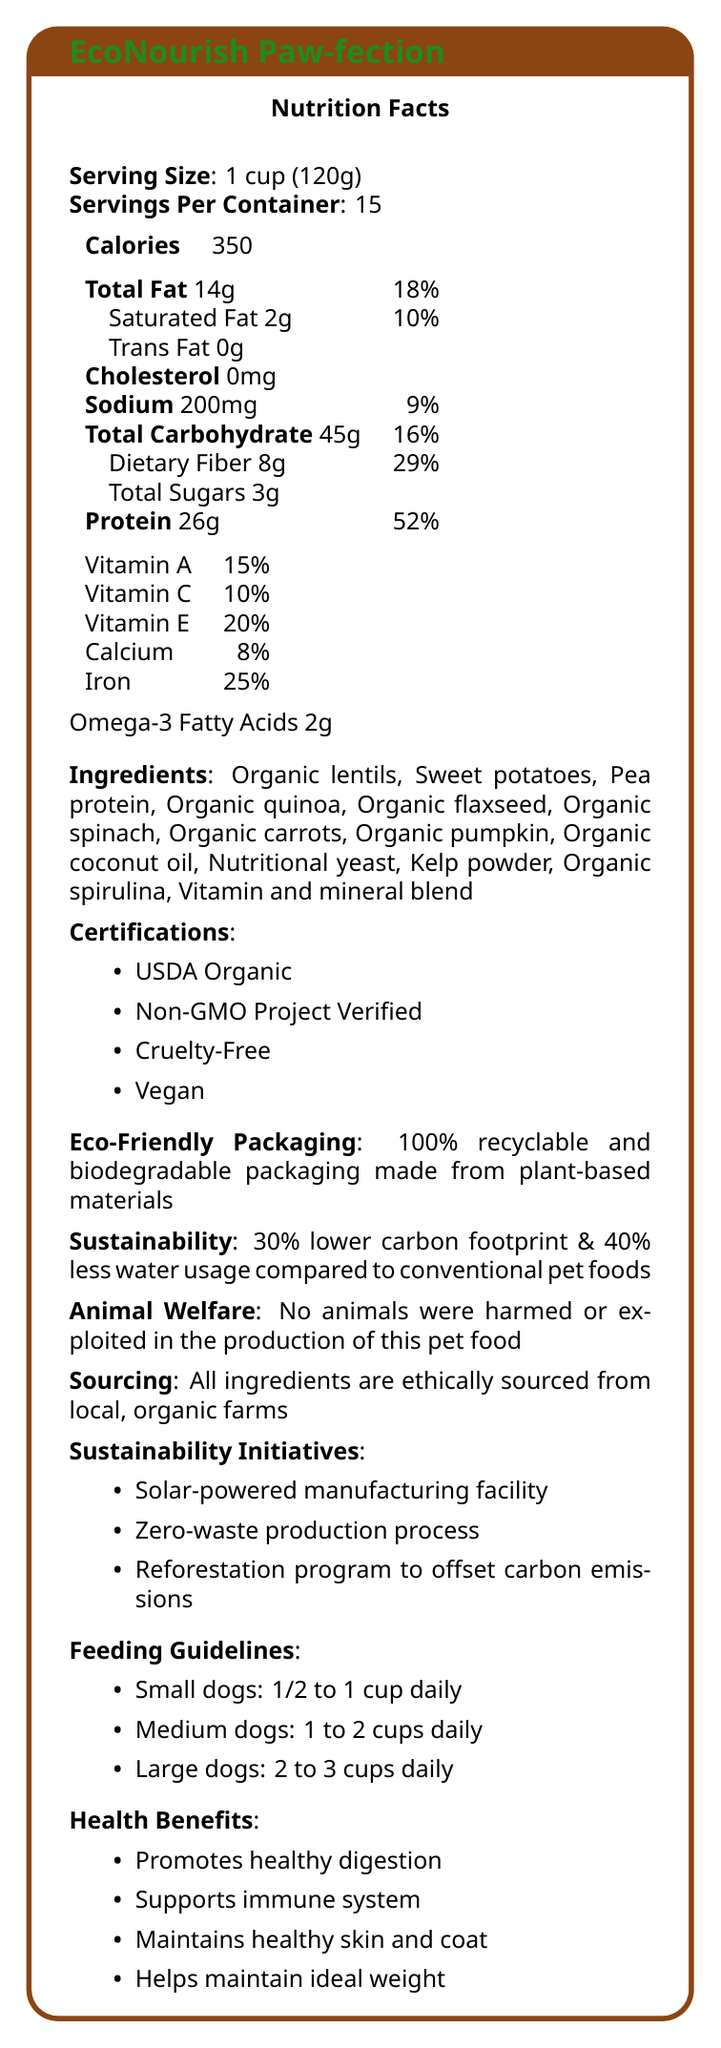How many servings are there per container? The document states that there are 15 servings per container.
Answer: 15 What is the serving size of EcoNourish Paw-fection? The serving size is listed as 1 cup (120g).
Answer: 1 cup (120g) How many grams of protein are in one serving? Under Nutrition Facts, it shows that Protein is 26g per serving.
Answer: 26g What are the omega-3 fatty acids content per serving? The document lists Omega-3 Fatty Acids as 2g.
Answer: 2g How many calories are in one serving? The document states there are 350 calories per serving.
Answer: 350 Which of the following ingredients is not listed in EcoNourish Paw-fection? A. Pea protein B. Organic quinoa C. Wheat D. Organic coconut oil Wheat is not listed among the ingredients; the other options are included in the list.
Answer: C What certification does EcoNourish Paw-fection have? A. USDA Organic B. Gluten-Free C. Fair Trade D. Kosher The certification listed under Certifications includes USDA Organic.
Answer: A Is any animal harmed or exploited in the production of this pet food? The document explicitly states under Animal Welfare that no animals were harmed or exploited in the production of this pet food.
Answer: No Summarize the main idea of the document. The document provides detailed information about the nutritional content, ethical and sustainable attributes, and health benefits of EcoNourish Paw-fection pet food.
Answer: EcoNourish Paw-fection is a plant-based, eco-friendly pet food that emphasizes animal welfare and environmental sustainability. It is high in protein, fiber, and omega-3 fatty acids and is certified organic, non-GMO, cruelty-free, and vegan. It also features eco-friendly packaging and sustainability initiatives like solar-powered manufacturing and zero-waste production processes. What is the daily value percentage of dietary fiber per serving? The daily value percentage of dietary fiber per serving is listed as 29%.
Answer: 29% What is the carbon footprint reduction of EcoNourish Paw-fection compared to conventional pet foods? The sustainability section specifies a 30% lower carbon footprint compared to conventional pet foods.
Answer: 30% What vitamins are included in EcoNourish Paw-fection? The document lists Vitamin A (15%), Vitamin C (10%), and Vitamin E (20%) under the vitamins section.
Answer: Vitamin A, Vitamin C, Vitamin E How many grams of total carbohydrate are there per serving? The document shows 45g of total carbohydrate per serving.
Answer: 45g Are the ingredients sourced from international farms? The document states that all ingredients are ethically sourced from local, organic farms.
Answer: No What type of packaging does EcoNourish Paw-fection use? The eco-friendly packaging section mentions that the packaging is 100% recyclable and biodegradable, made from plant-based materials.
Answer: 100% recyclable and biodegradable packaging made from plant-based materials What is the calcium content per serving, and why could this be considered insufficient for some pet diets? The daily value of calcium per serving is 8%. This might be considered insufficient for pets that require higher calcium intake for bone health, making it necessary to supplement with other sources.
Answer: 8% Where is the manufacturing facility of EcoNourish Paw-fection? The document does not provide specific details about the location of the manufacturing facility.
Answer: Not enough information What is the recommended feeding guideline for medium dogs? The feeding guidelines section states that medium dogs should be fed 1 to 2 cups daily.
Answer: 1 to 2 cups daily What should one look for to verify the cruelty-free claim of EcoNourish Paw-fection? The cruelty-free certification is mentioned under Certifications, which verifies the pet food's cruelty-free status.
Answer: Certifications 